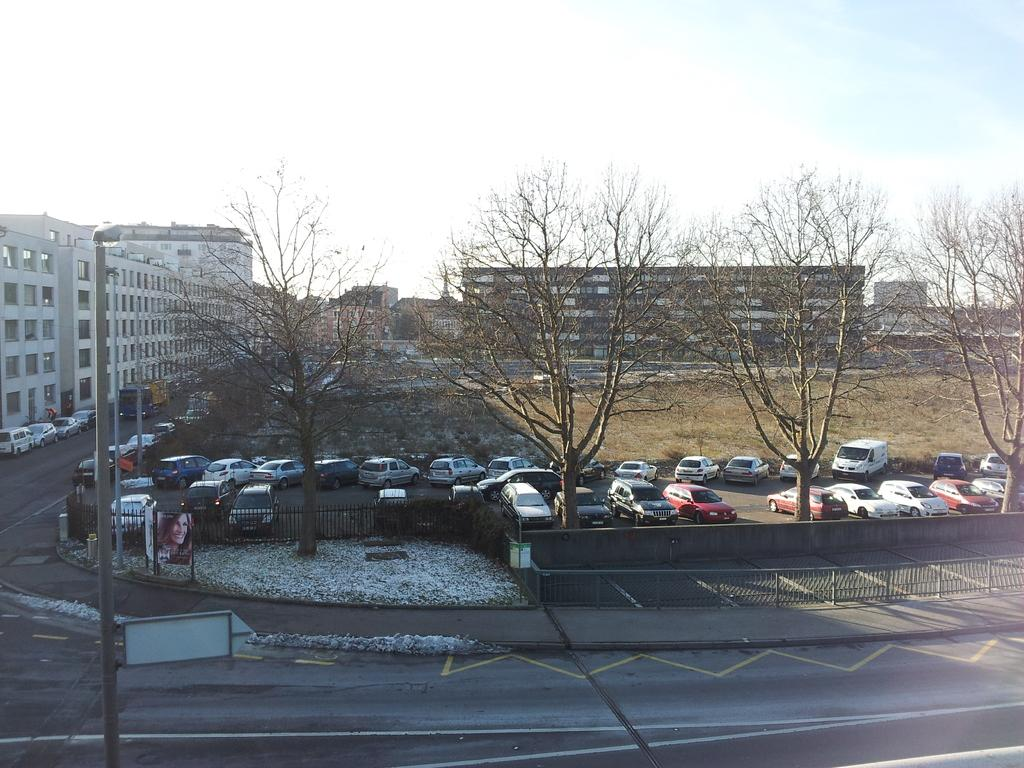What can be seen in the sky in the image? The sky with clouds is visible in the image. What structures are present in the image? Poles and fences are present in the image. What is the ground condition in the image? There is snow visible in the image. What type of vegetation is present in the image? Trees are present in the image. What type of transportation is on the ground in the image? Motor vehicles are on the ground in the image. What type of signage is present in the image? Advertisement boards are in the image. Can you see a flame coming out of the clouds in the image? No, there is no flame visible in the image; only clouds are present in the sky. What type of act is being performed by the clouds in the image? The clouds are not performing any act in the image; they are simply part of the sky's natural appearance. 